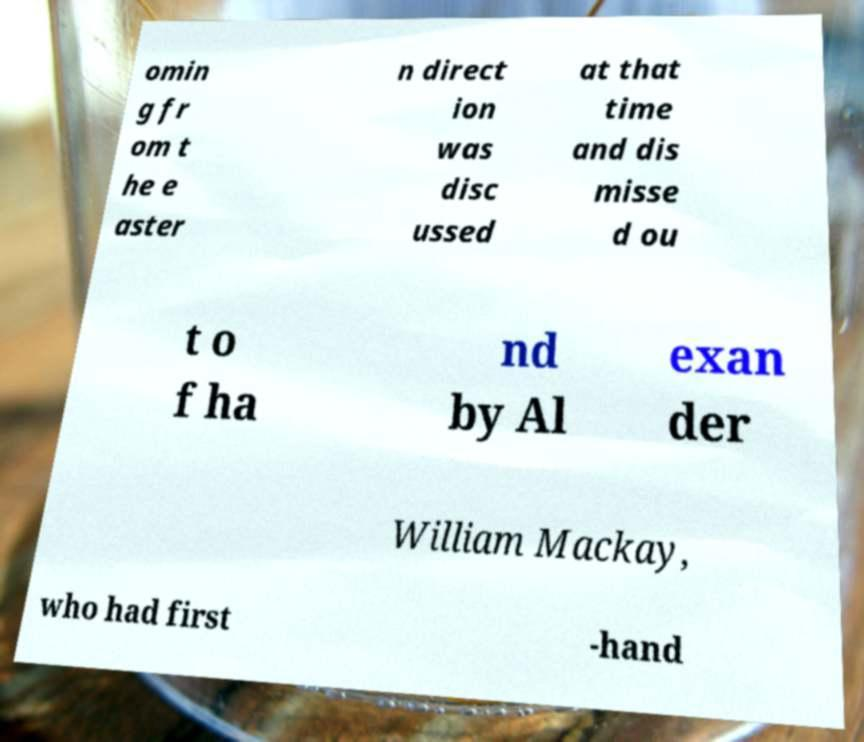Please read and relay the text visible in this image. What does it say? omin g fr om t he e aster n direct ion was disc ussed at that time and dis misse d ou t o f ha nd by Al exan der William Mackay, who had first -hand 